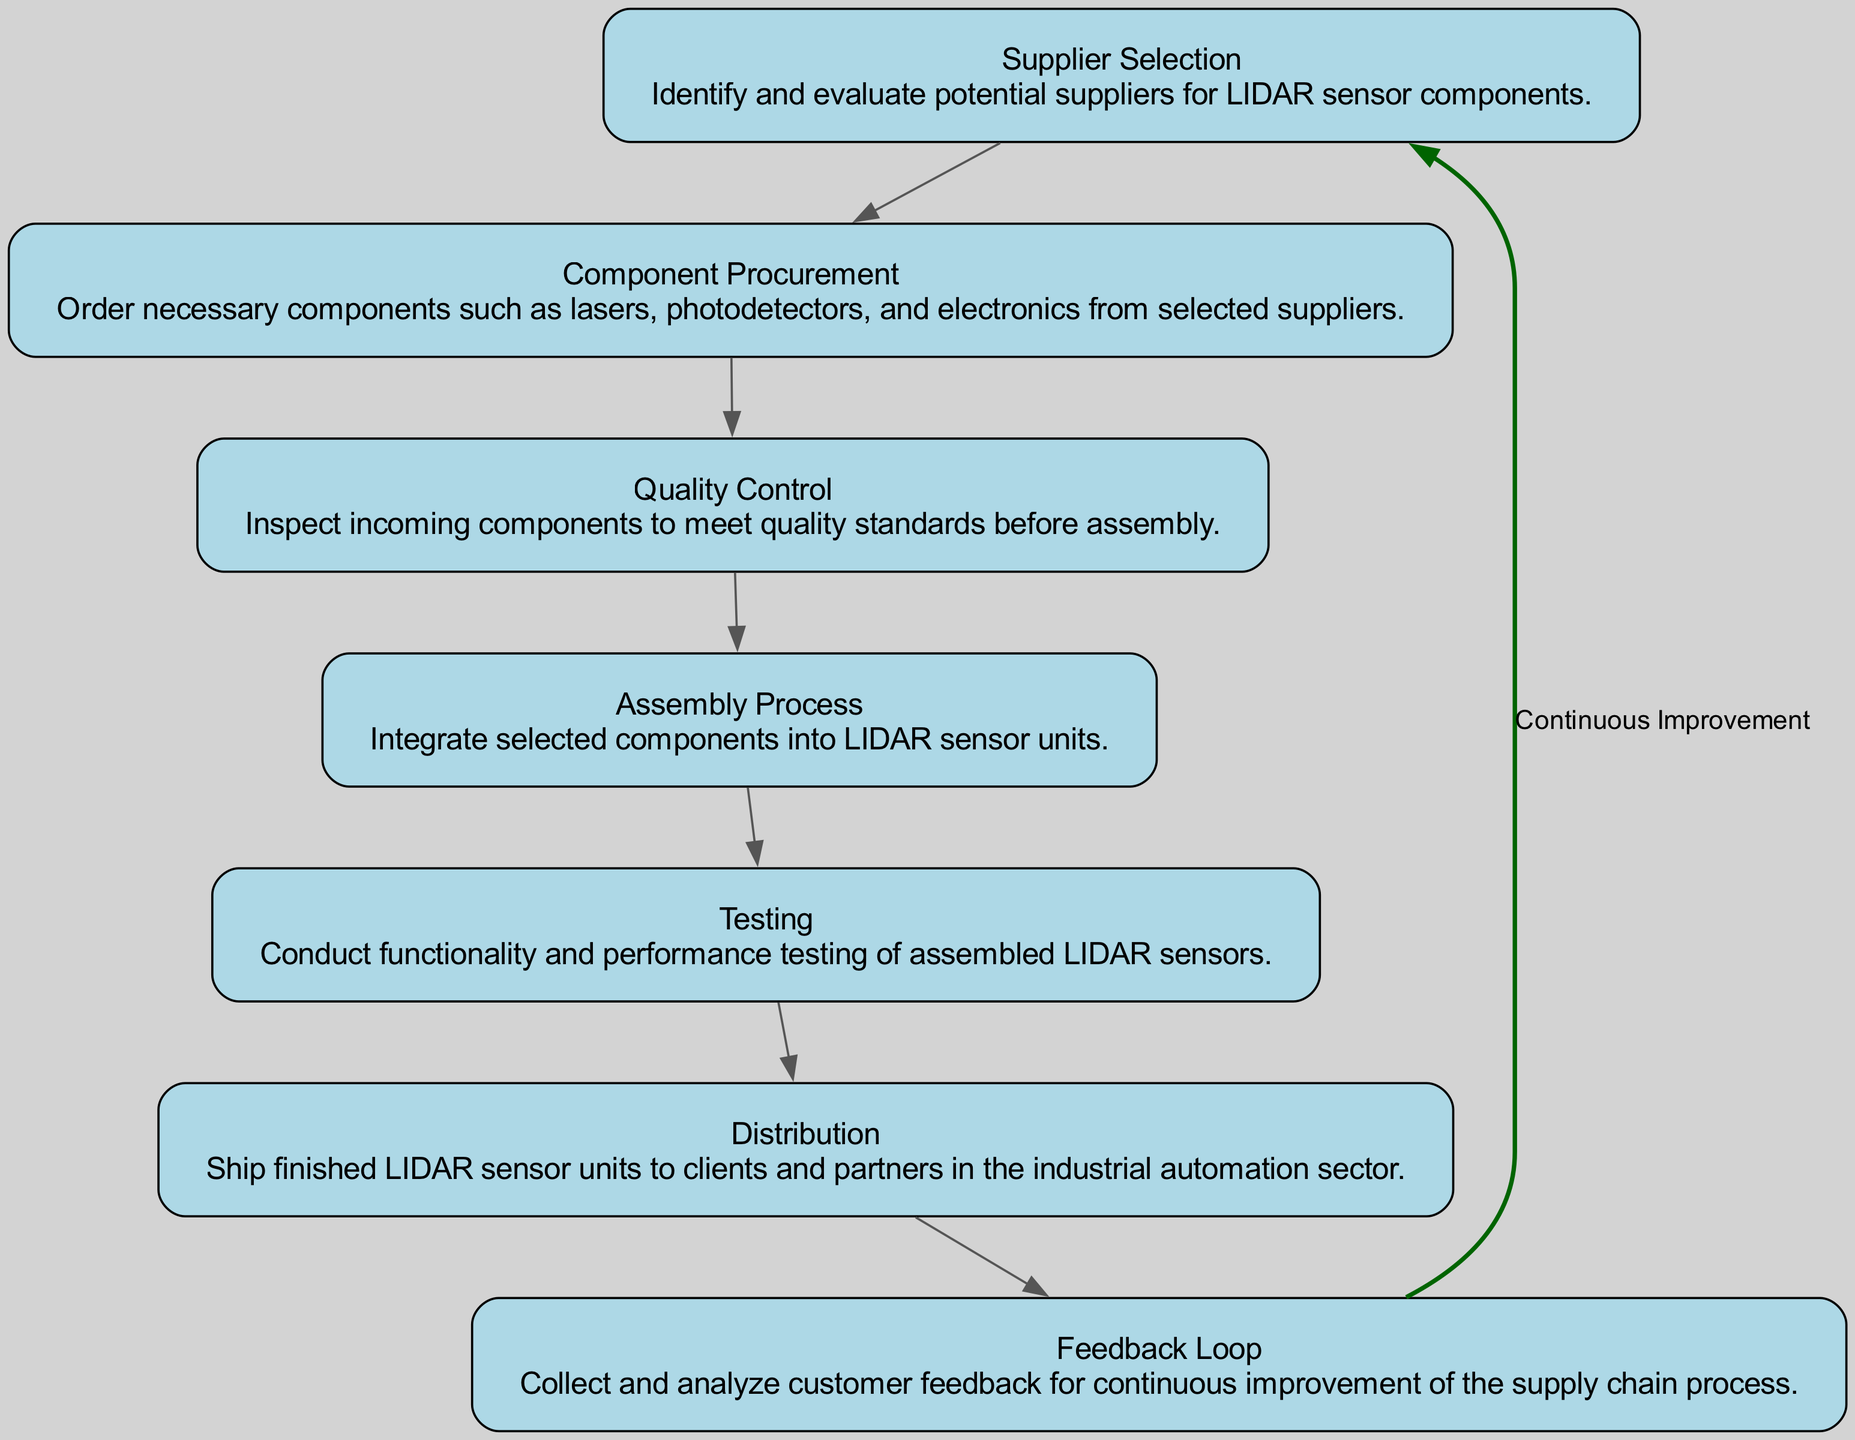What is the first step in the supply chain workflow? The diagram indicates that the first step is "Supplier Selection," which involves identifying and evaluating potential suppliers for LIDAR sensor components.
Answer: Supplier Selection How many main steps are there in the supply chain workflow? By counting each element in the diagram, we find there are a total of seven main steps including Supplier Selection, Component Procurement, Quality Control, Assembly Process, Testing, Distribution, and Feedback Loop.
Answer: Seven What is the last step in the workflow? The last step in the workflow shown in the diagram is "Distribution," which involves shipping finished LIDAR sensor units to clients and partners.
Answer: Distribution What connects the "Feedback Loop" back to the "Supplier Selection"? The diagram shows a labeled edge indicating "Continuous Improvement" from the "Feedback Loop" back to the "Supplier Selection," signifying a cycle where feedback is used to improve the selection process.
Answer: Continuous Improvement What is performed after the "Assembly Process"? According to the diagram, the step that follows the "Assembly Process" is "Testing," where functionality and performance testing of assembled LIDAR sensors is conducted.
Answer: Testing Which step involves inspecting incoming components? The diagram specifies that "Quality Control" is the step focused on inspecting incoming components to ensure they meet quality standards before assembly.
Answer: Quality Control How many components are grouped in the supply chain workflow leading to the "Testing" step? The elements that flow into the "Testing" step are two: "Assembly Process" and "Quality Control." Therefore, there are two components leading up to the Testing step.
Answer: Two What is the main focus of the "Feedback Loop"? The diagram indicates that the main focus of the "Feedback Loop" is to collect and analyze customer feedback, which is crucial for continual improvement of the supply chain process.
Answer: Customer feedback analysis What step comes immediately before "Distribution"? The diagram clearly shows that "Testing" immediately precedes "Distribution," indicating that the finished sensors are tested before they are shipped out.
Answer: Testing 